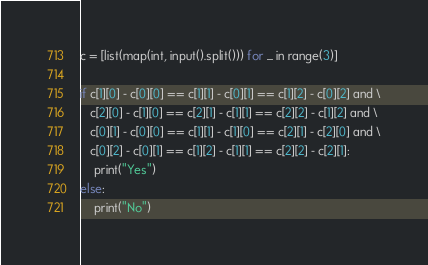Convert code to text. <code><loc_0><loc_0><loc_500><loc_500><_Python_>c = [list(map(int, input().split())) for _ in range(3)]

if c[1][0] - c[0][0] == c[1][1] - c[0][1] == c[1][2] - c[0][2] and \
   c[2][0] - c[1][0] == c[2][1] - c[1][1] == c[2][2] - c[1][2] and \
   c[0][1] - c[0][0] == c[1][1] - c[1][0] == c[2][1] - c[2][0] and \
   c[0][2] - c[0][1] == c[1][2] - c[1][1] == c[2][2] - c[2][1]:
    print("Yes")
else:
    print("No")
</code> 